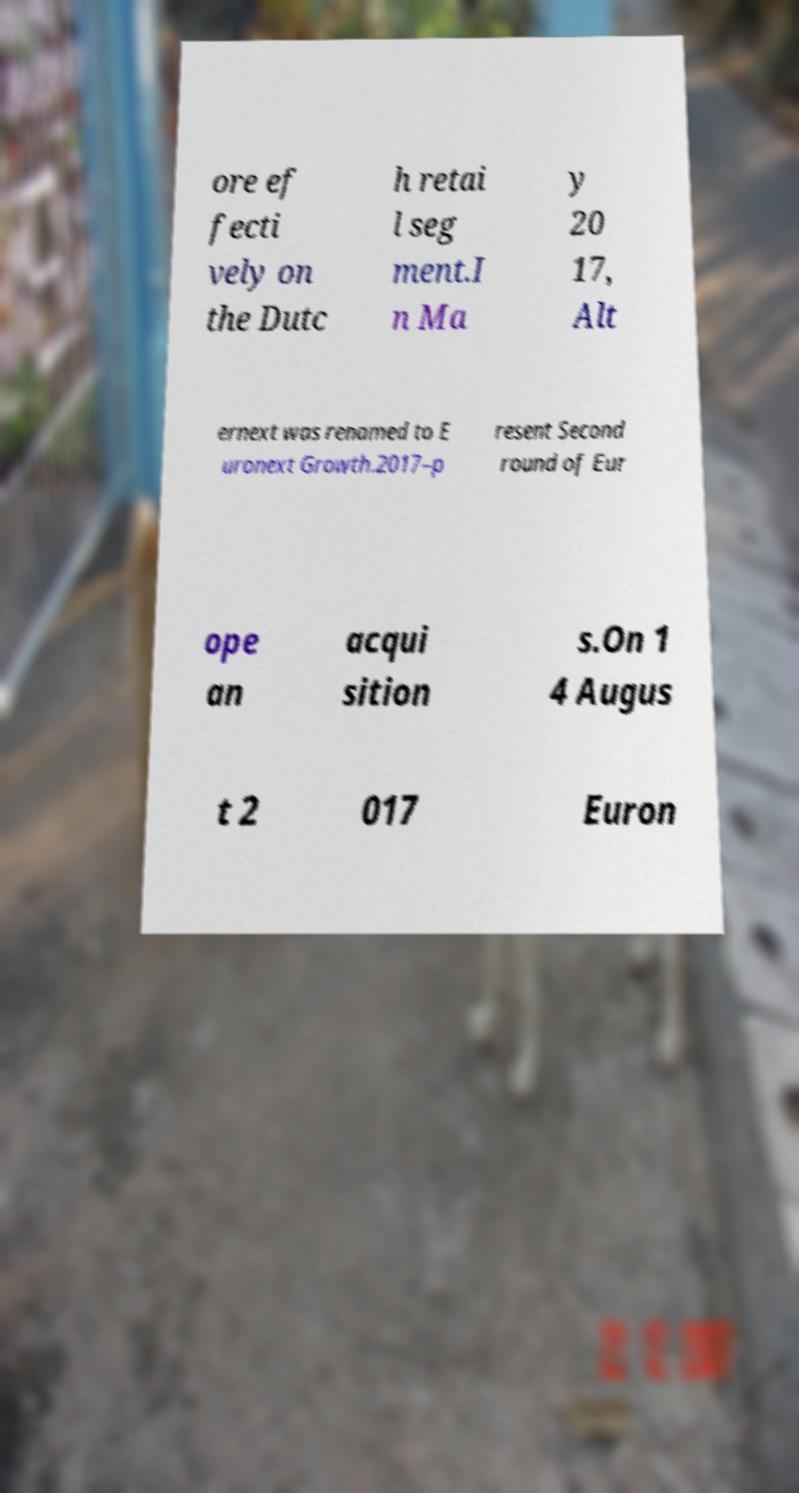Can you read and provide the text displayed in the image?This photo seems to have some interesting text. Can you extract and type it out for me? ore ef fecti vely on the Dutc h retai l seg ment.I n Ma y 20 17, Alt ernext was renamed to E uronext Growth.2017–p resent Second round of Eur ope an acqui sition s.On 1 4 Augus t 2 017 Euron 